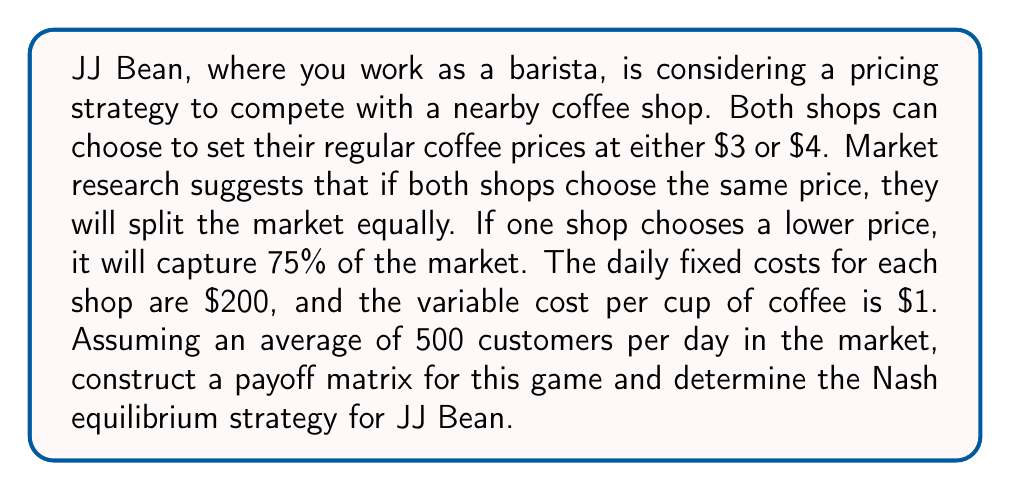Provide a solution to this math problem. Let's approach this step-by-step:

1) First, we need to calculate the payoffs for each scenario. The payoff will be the profit, which is (Revenue - Costs).

2) Revenue calculation:
   - If prices are the same: 250 customers * price
   - If one price is lower: 375 customers * price (for lower price), 125 customers * price (for higher price)

3) Cost calculation: $200 fixed cost + $1 * number of customers served

4) Let's calculate the payoffs for each scenario:

   a) Both choose $3:
      JJ Bean: $(250 * 3) - (200 + 250 * 1) = $300
      Competitor: $300

   b) JJ Bean chooses $3, Competitor chooses $4:
      JJ Bean: $(375 * 3) - (200 + 375 * 1) = $575
      Competitor: $(125 * 4) - (200 + 125 * 1) = $175

   c) JJ Bean chooses $4, Competitor chooses $3:
      JJ Bean: $(125 * 4) - (200 + 125 * 1) = $175
      Competitor: $(375 * 3) - (200 + 375 * 1) = $575

   d) Both choose $4:
      JJ Bean: $(250 * 4) - (200 + 250 * 1) = $550
      Competitor: $550

5) Now we can construct the payoff matrix:

   $$
   \begin{array}{c|c|c}
    & \text{Competitor } \$3 & \text{Competitor } \$4 \\
   \hline
   \text{JJ Bean } \$3 & (300, 300) & (575, 175) \\
   \hline
   \text{JJ Bean } \$4 & (175, 575) & (550, 550)
   \end{array}
   $$

6) To find the Nash equilibrium, we need to check if any player has an incentive to unilaterally change their strategy:

   - If Competitor chooses $3, JJ Bean's best response is $3 (300 > 175)
   - If Competitor chooses $4, JJ Bean's best response is $3 (575 > 550)
   - If JJ Bean chooses $3, Competitor's best response is $3 (300 > 175)
   - If JJ Bean chooses $4, Competitor's best response is $3 (575 > 550)

7) We can see that ($3, $3) is the only Nash equilibrium, as neither player has an incentive to unilaterally deviate from this strategy.
Answer: The Nash equilibrium strategy for JJ Bean is to price their regular coffee at $3. The payoff matrix is:

$$
\begin{array}{c|c|c}
 & \text{Competitor } \$3 & \text{Competitor } \$4 \\
\hline
\text{JJ Bean } \$3 & (300, 300) & (575, 175) \\
\hline
\text{JJ Bean } \$4 & (175, 575) & (550, 550)
\end{array}
$$

The unique Nash equilibrium is ($3, $3), where both JJ Bean and the competitor price their coffee at $3. 